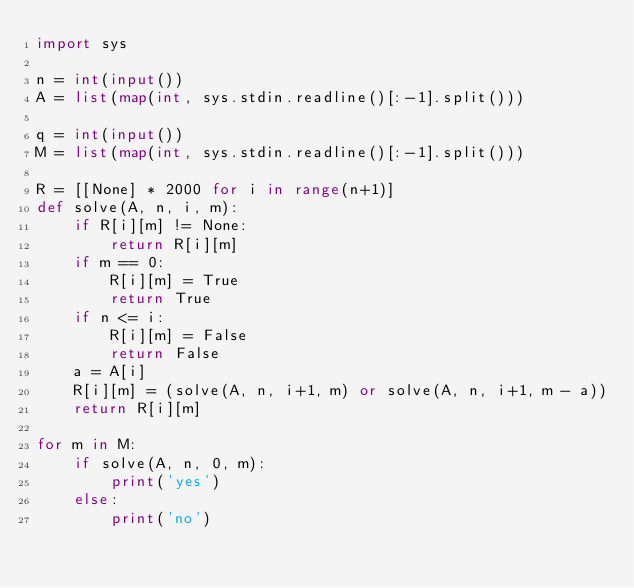<code> <loc_0><loc_0><loc_500><loc_500><_Python_>import sys

n = int(input())
A = list(map(int, sys.stdin.readline()[:-1].split()))

q = int(input())
M = list(map(int, sys.stdin.readline()[:-1].split()))

R = [[None] * 2000 for i in range(n+1)]
def solve(A, n, i, m):
    if R[i][m] != None:
        return R[i][m]
    if m == 0:
        R[i][m] = True
        return True
    if n <= i:
        R[i][m] = False
        return False
    a = A[i]
    R[i][m] = (solve(A, n, i+1, m) or solve(A, n, i+1, m - a))
    return R[i][m]

for m in M:
    if solve(A, n, 0, m):
        print('yes')
    else:
        print('no')</code> 